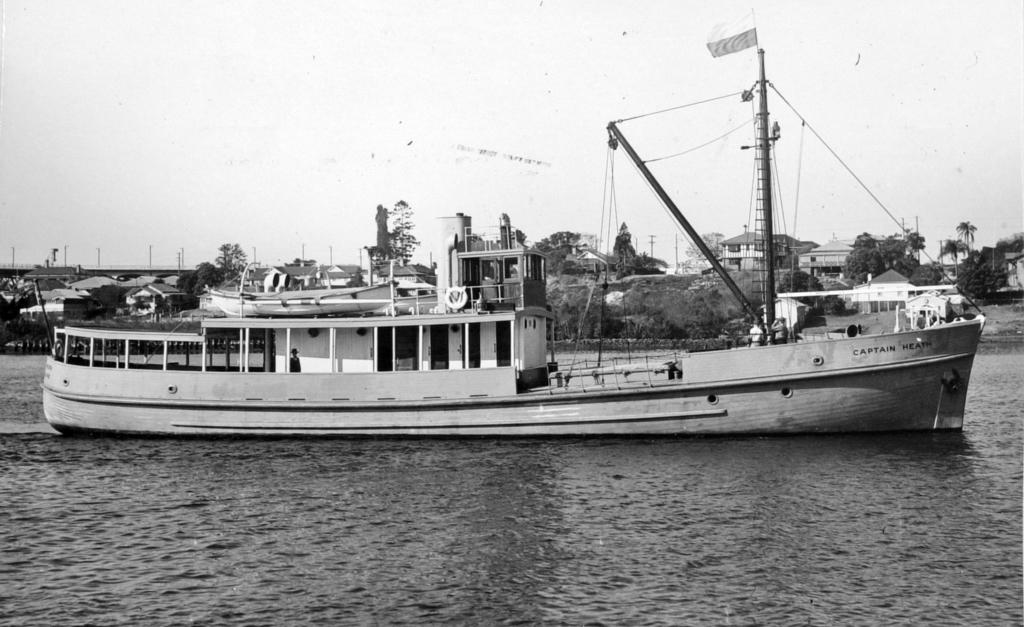What is the main subject of the image? The main subject of the image is a ship on the water. What else can be seen in the image besides the ship? There are buildings, hills, trees, poles, and the sky visible in the image. Can you describe the landscape in the image? The image features a combination of natural elements, such as hills and trees, and man-made structures, like buildings and poles. What type of cloth is draped over the ship's mast in the image? There is no cloth draped over the ship's mast in the image. What kind of lace patterns can be seen on the trees in the image? There are no lace patterns present on the trees in the image; they are natural trees without any decorative elements. 